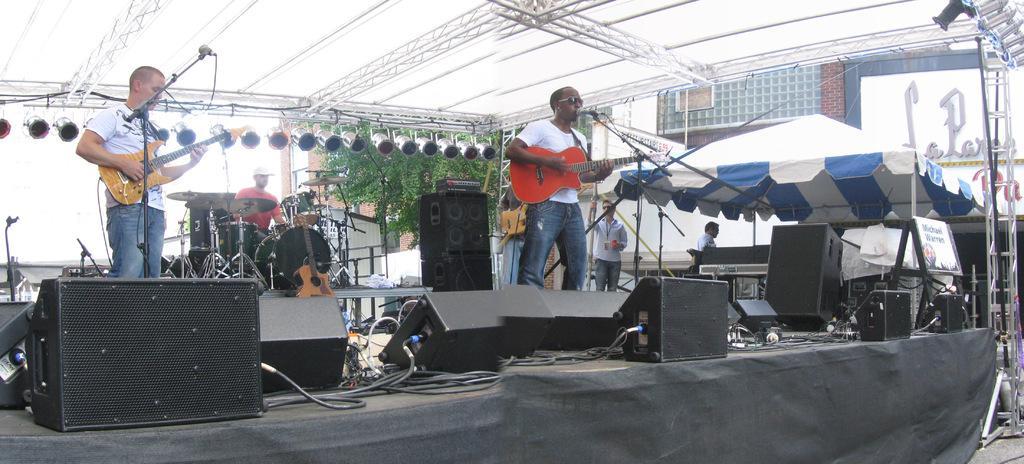How would you summarize this image in a sentence or two? This is a stage,on the stage there are 3 people performing by playing musical instruments. Above them there is a tent and poles. On the right we can see a building,tent,speakers. lighting,banners. 